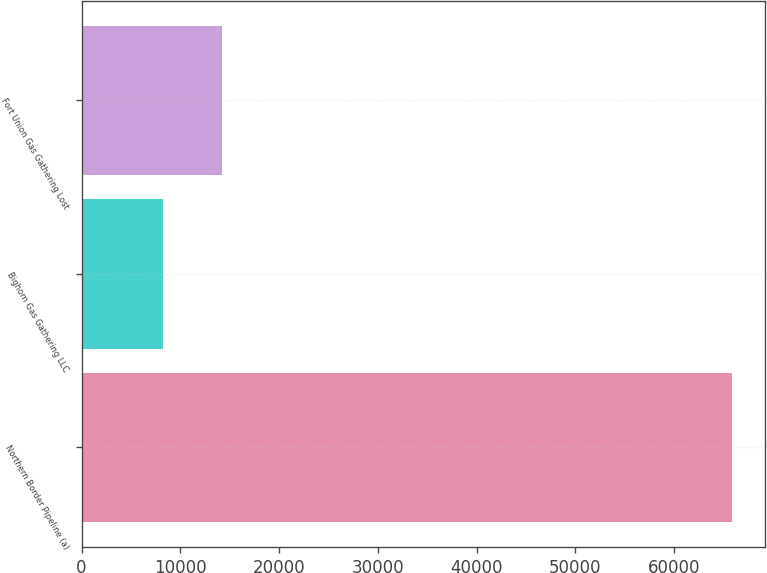Convert chart. <chart><loc_0><loc_0><loc_500><loc_500><bar_chart><fcel>Northern Border Pipeline (a)<fcel>Bighorn Gas Gathering LLC<fcel>Fort Union Gas Gathering Lost<nl><fcel>65912<fcel>8195<fcel>14172<nl></chart> 